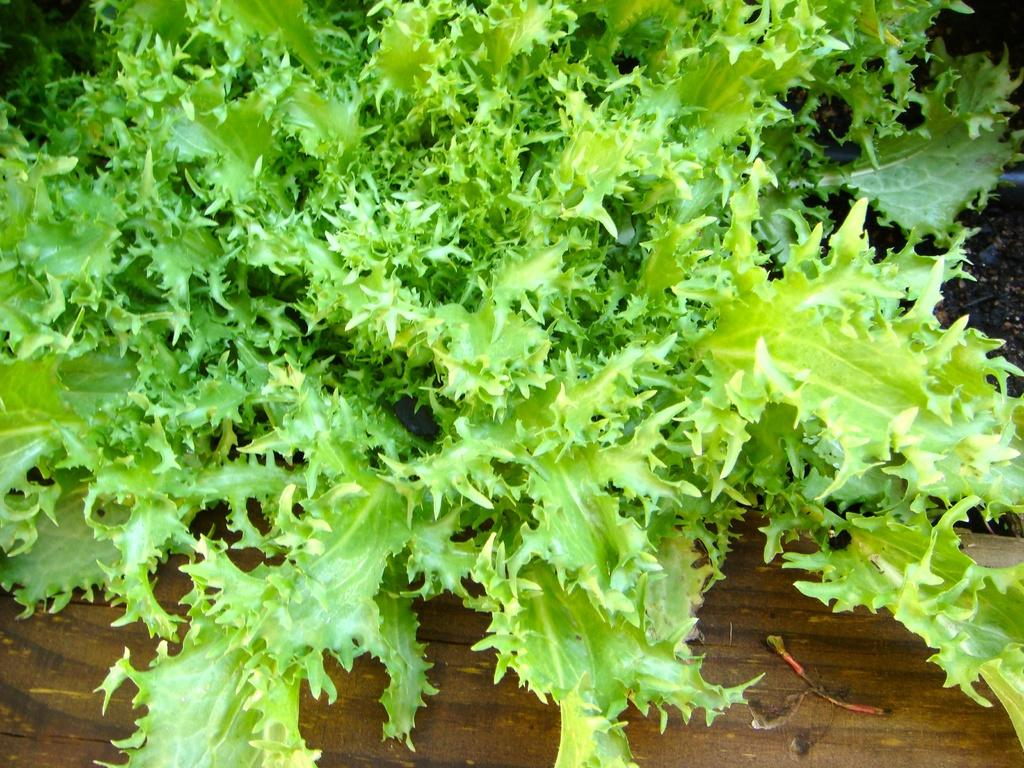What type of living organisms can be seen in the image? Plants can be seen in the image. What type of border is visible in the image? There is no border present in the image; it only features plants. Can you read any writing on the plants in the image? Plants do not have the ability to have writing on them, so there is no writing visible in the image. 